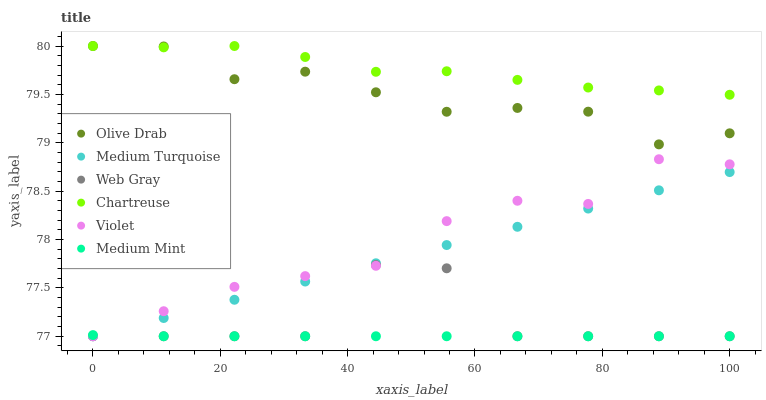Does Medium Mint have the minimum area under the curve?
Answer yes or no. Yes. Does Chartreuse have the maximum area under the curve?
Answer yes or no. Yes. Does Web Gray have the minimum area under the curve?
Answer yes or no. No. Does Web Gray have the maximum area under the curve?
Answer yes or no. No. Is Medium Turquoise the smoothest?
Answer yes or no. Yes. Is Web Gray the roughest?
Answer yes or no. Yes. Is Chartreuse the smoothest?
Answer yes or no. No. Is Chartreuse the roughest?
Answer yes or no. No. Does Medium Mint have the lowest value?
Answer yes or no. Yes. Does Chartreuse have the lowest value?
Answer yes or no. No. Does Olive Drab have the highest value?
Answer yes or no. Yes. Does Web Gray have the highest value?
Answer yes or no. No. Is Web Gray less than Chartreuse?
Answer yes or no. Yes. Is Chartreuse greater than Web Gray?
Answer yes or no. Yes. Does Medium Turquoise intersect Web Gray?
Answer yes or no. Yes. Is Medium Turquoise less than Web Gray?
Answer yes or no. No. Is Medium Turquoise greater than Web Gray?
Answer yes or no. No. Does Web Gray intersect Chartreuse?
Answer yes or no. No. 